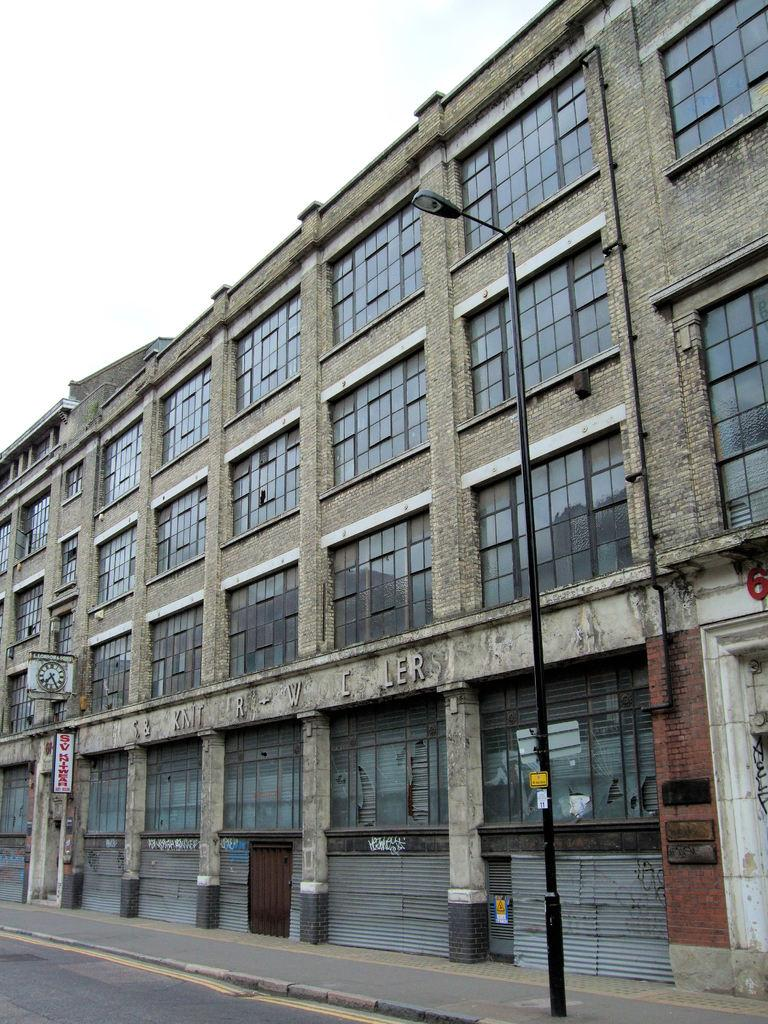What type of structure is featured in the image? There is a building with text in the image. What is attached to the pole in the image? There is a light attached to the pole in the image. What type of surface is visible in the foreground of the image? There is a sidewalk in the foreground of the image. What is visible at the top of the image? The sky is visible at the top of the image. What type of pathway is visible at the bottom of the image? There is a road at the bottom of the image. What type of collar can be seen on the advertisement in the image? There is no collar or advertisement present in the image. What is the source of the surprise in the image? There is no surprise or indication of surprise in the image. 